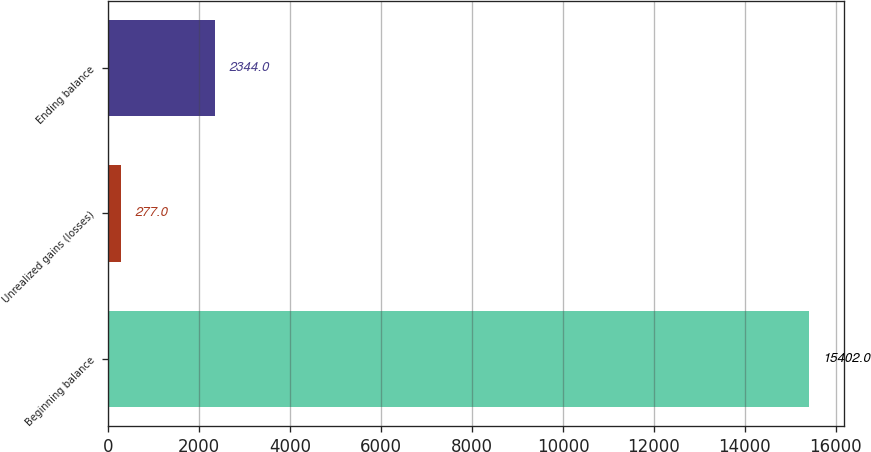<chart> <loc_0><loc_0><loc_500><loc_500><bar_chart><fcel>Beginning balance<fcel>Unrealized gains (losses)<fcel>Ending balance<nl><fcel>15402<fcel>277<fcel>2344<nl></chart> 